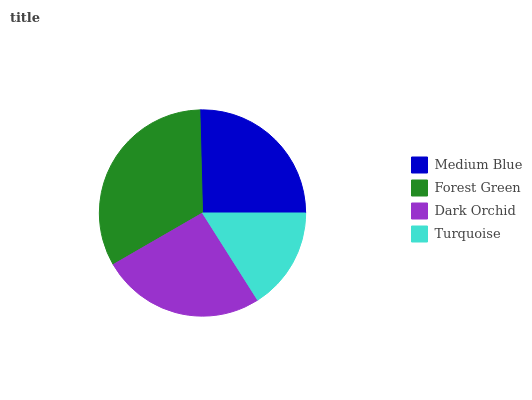Is Turquoise the minimum?
Answer yes or no. Yes. Is Forest Green the maximum?
Answer yes or no. Yes. Is Dark Orchid the minimum?
Answer yes or no. No. Is Dark Orchid the maximum?
Answer yes or no. No. Is Forest Green greater than Dark Orchid?
Answer yes or no. Yes. Is Dark Orchid less than Forest Green?
Answer yes or no. Yes. Is Dark Orchid greater than Forest Green?
Answer yes or no. No. Is Forest Green less than Dark Orchid?
Answer yes or no. No. Is Dark Orchid the high median?
Answer yes or no. Yes. Is Medium Blue the low median?
Answer yes or no. Yes. Is Medium Blue the high median?
Answer yes or no. No. Is Forest Green the low median?
Answer yes or no. No. 